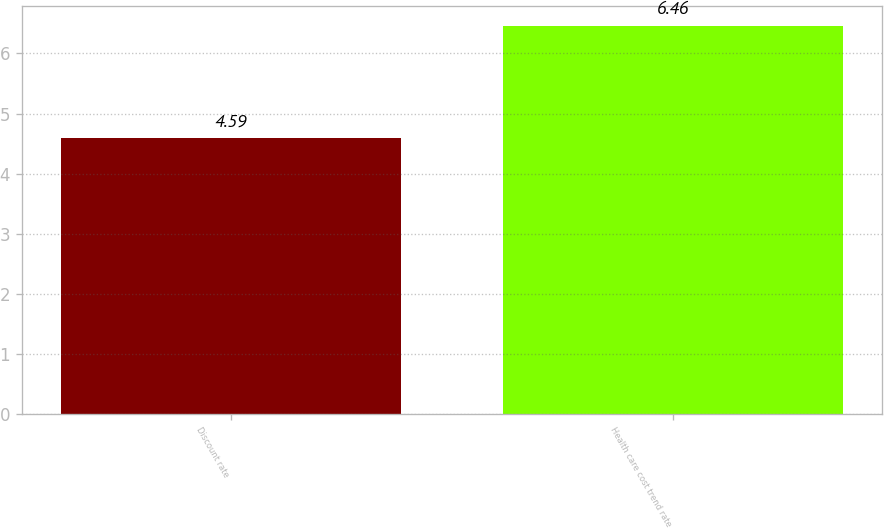Convert chart. <chart><loc_0><loc_0><loc_500><loc_500><bar_chart><fcel>Discount rate<fcel>Health care cost trend rate<nl><fcel>4.59<fcel>6.46<nl></chart> 